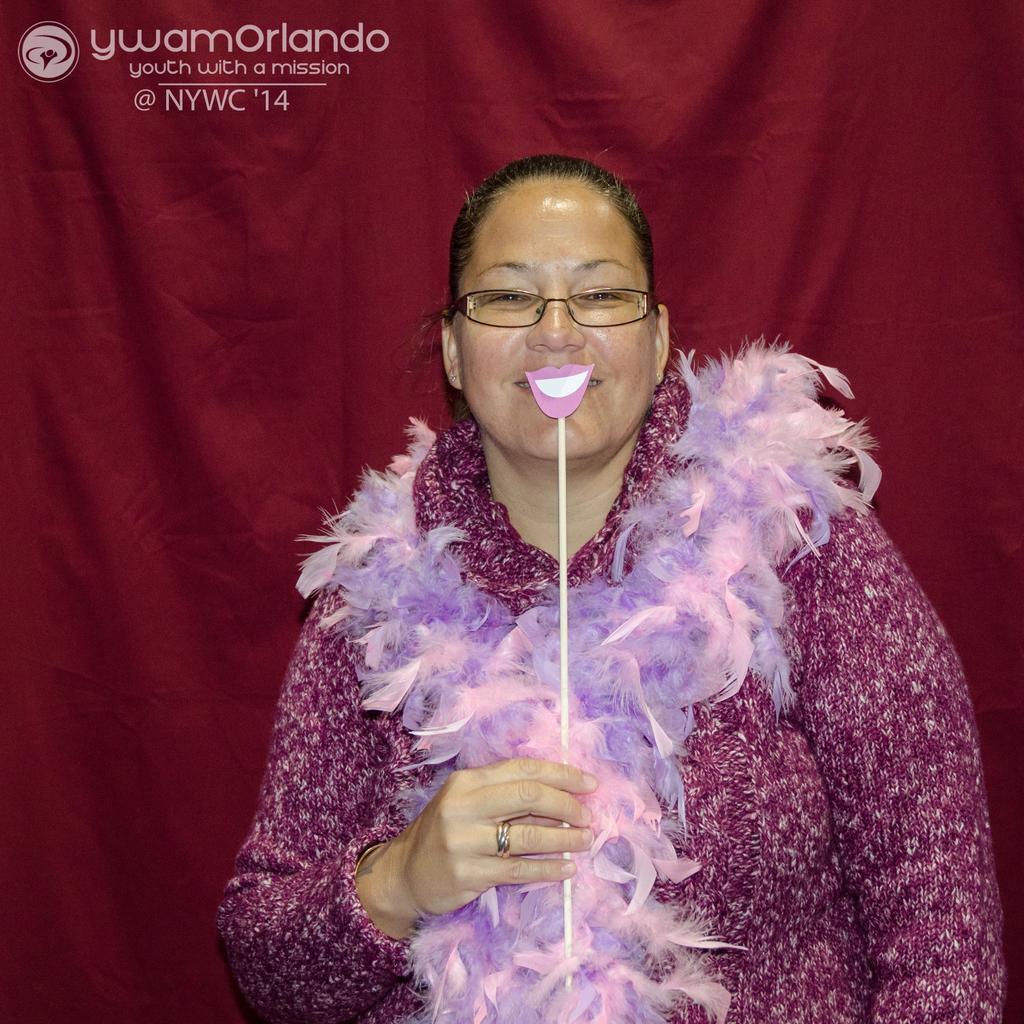In one or two sentences, can you explain what this image depicts? In this image we can see a woman standing holding a stick. On the backside we can see a curtain. 